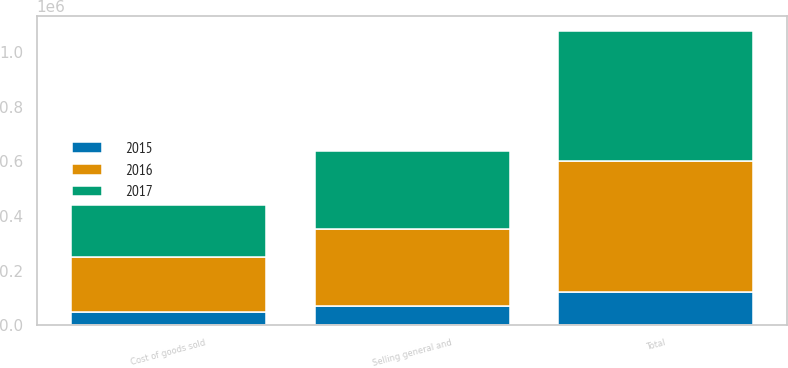Convert chart. <chart><loc_0><loc_0><loc_500><loc_500><stacked_bar_chart><ecel><fcel>Cost of goods sold<fcel>Selling general and<fcel>Total<nl><fcel>2017<fcel>190792<fcel>283000<fcel>473792<nl><fcel>2016<fcel>199257<fcel>283000<fcel>482257<nl><fcel>2015<fcel>49583<fcel>70750<fcel>120333<nl></chart> 